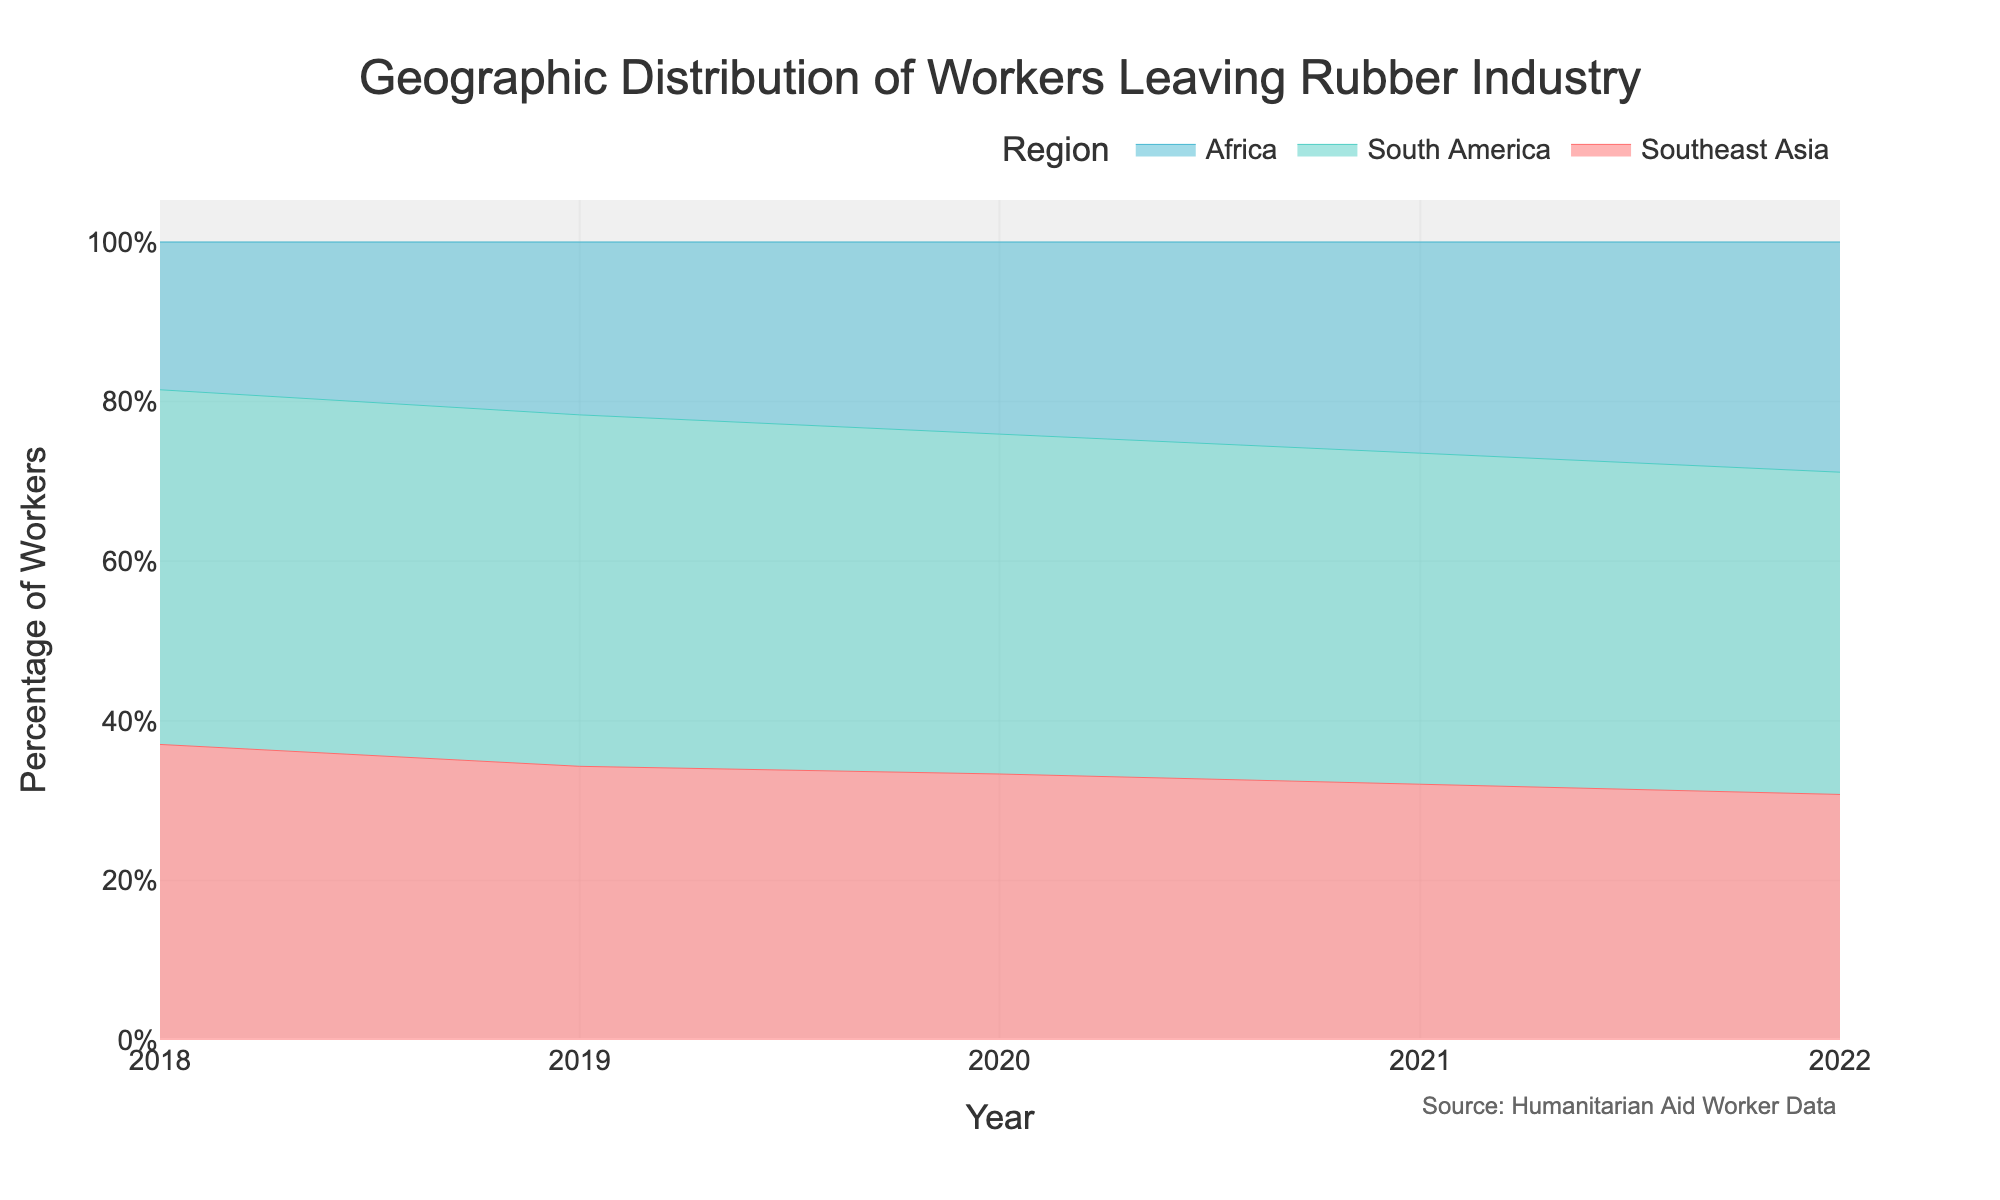What's the title of the figure? The title of the figure is located at the top center of the plot.
Answer: Geographic Distribution of Workers Leaving Rubber Industry How does the number of workers from Southeast Asia change from 2018 to 2022? From the plot, the number of workers from Southeast Asia decreases consistently from 1000 in 2018 to 800 in 2022.
Answer: Decreases Which region had the highest percentage of workers leaving the rubber industry in 2022? By analyzing the stacked area plot for 2022, South America occupies the largest area, indicating the highest percentage of workers.
Answer: South America What trend can be observed in the number of workers leaving the rubber industry in Africa from 2018 to 2022? The trend for Africa shows a consistent increase in the number of workers from 500 in 2018 to 750 in 2022.
Answer: Increasing In what year did South America have the peak number of workers transitioning out of the rubber industry? From the chart, South America had the peak number of workers in 2019, with 1220 workers.
Answer: 2019 Between which years did Southeast Asia see the steepest decline in the number of workers? The steepest decline for Southeast Asia is observed between 2018 and 2019, where the number of workers drops from 1000 to 950.
Answer: 2018-2019 Compare the changes in the number of workers from South America and Africa between 2018 and 2022. South America workers increased slightly and then decreased from 1200 in 2018 to 1050 in 2022, while African workers consistently increased from 500 in 2018 to 750 in 2022.
Answer: South America decreased, Africa increased What is the overall trend in the total number of workers leaving the rubber industry across all regions from 2019 to 2022? By summing the number of workers for each year, the total decreases from 2770 in 2019 to 2600 in 2022.
Answer: Decreasing What percentage of workers were from Southeast Asia in 2020? In 2020, the number of workers from Southeast Asia (900) divided by the total number (2700) and multiplied by 100 results in approximately 33.33%.
Answer: 33.33% 